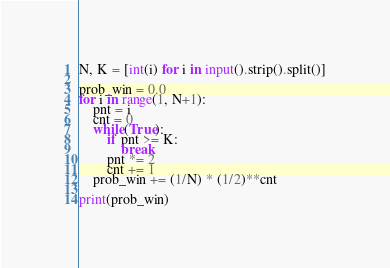Convert code to text. <code><loc_0><loc_0><loc_500><loc_500><_Python_>N, K = [int(i) for i in input().strip().split()]

prob_win = 0.0
for i in range(1, N+1):
    pnt = i
    cnt = 0
    while(True):
        if pnt >= K:
            break
        pnt *= 2
        cnt += 1
    prob_win += (1/N) * (1/2)**cnt

print(prob_win)
</code> 